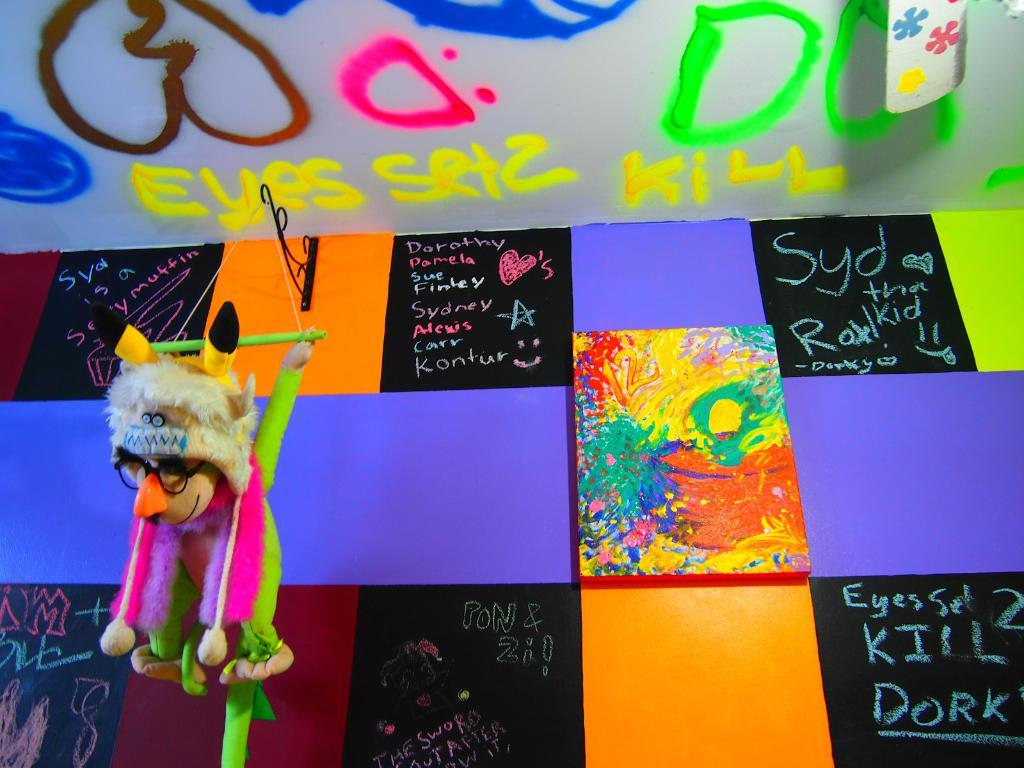<image>
Share a concise interpretation of the image provided. A stuffed animal hanging from the ceiling and chalk boards with messages including one from Sydney, Dorothy, and Pamela among others. 